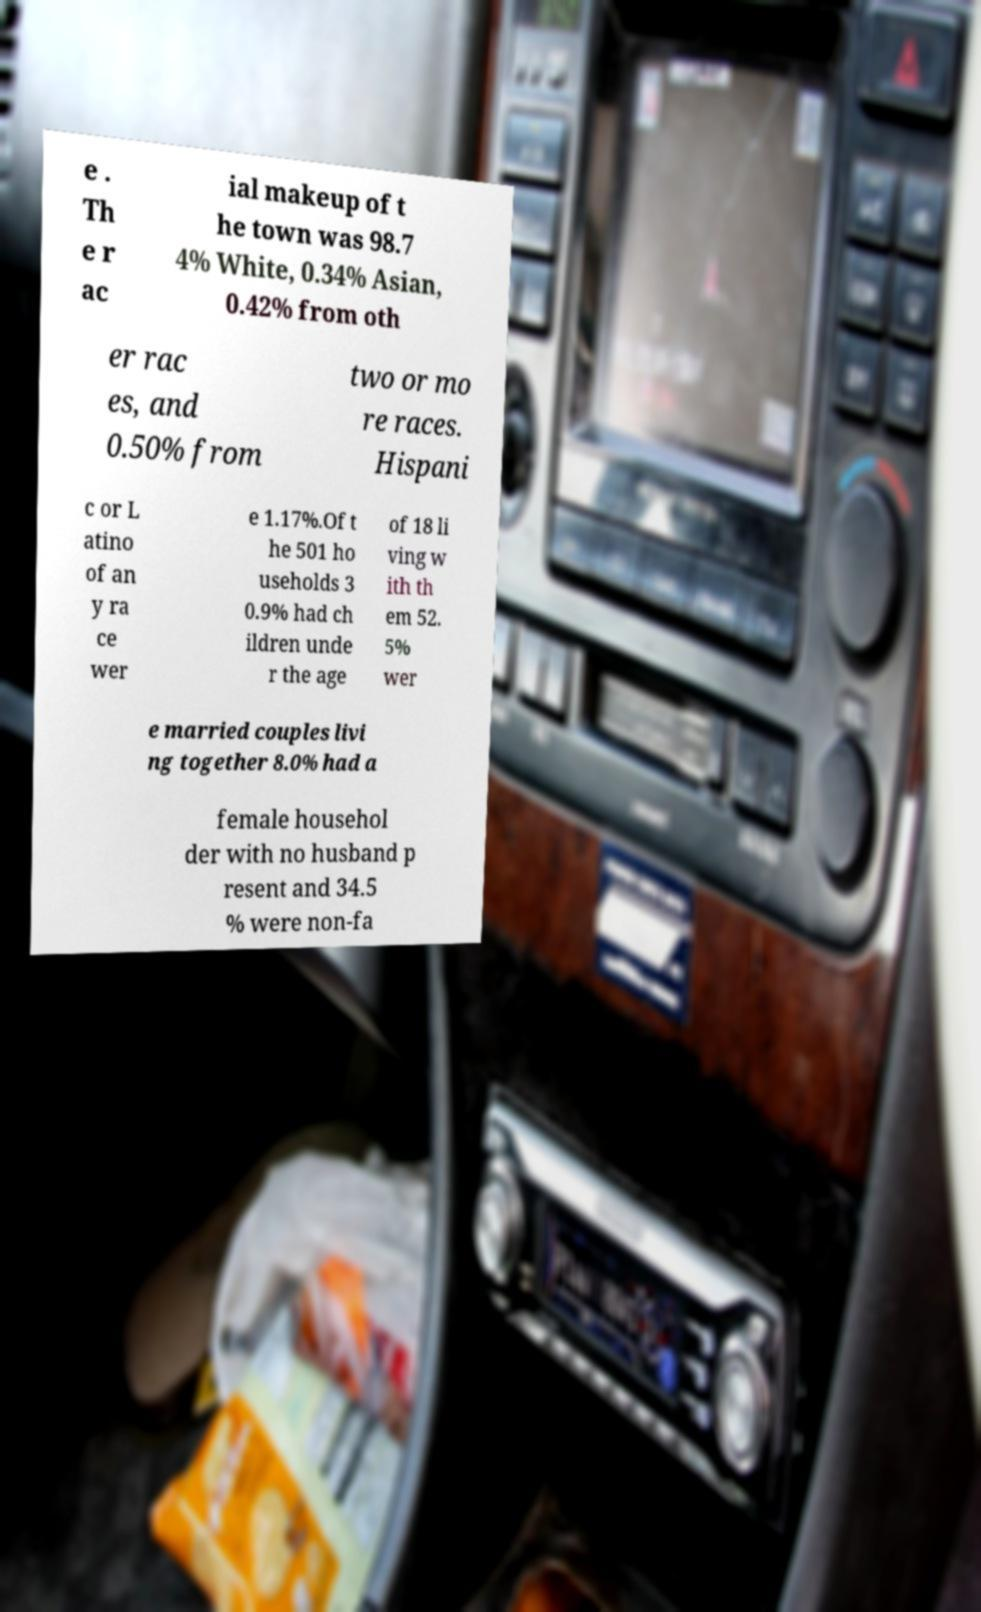Can you read and provide the text displayed in the image?This photo seems to have some interesting text. Can you extract and type it out for me? e . Th e r ac ial makeup of t he town was 98.7 4% White, 0.34% Asian, 0.42% from oth er rac es, and 0.50% from two or mo re races. Hispani c or L atino of an y ra ce wer e 1.17%.Of t he 501 ho useholds 3 0.9% had ch ildren unde r the age of 18 li ving w ith th em 52. 5% wer e married couples livi ng together 8.0% had a female househol der with no husband p resent and 34.5 % were non-fa 